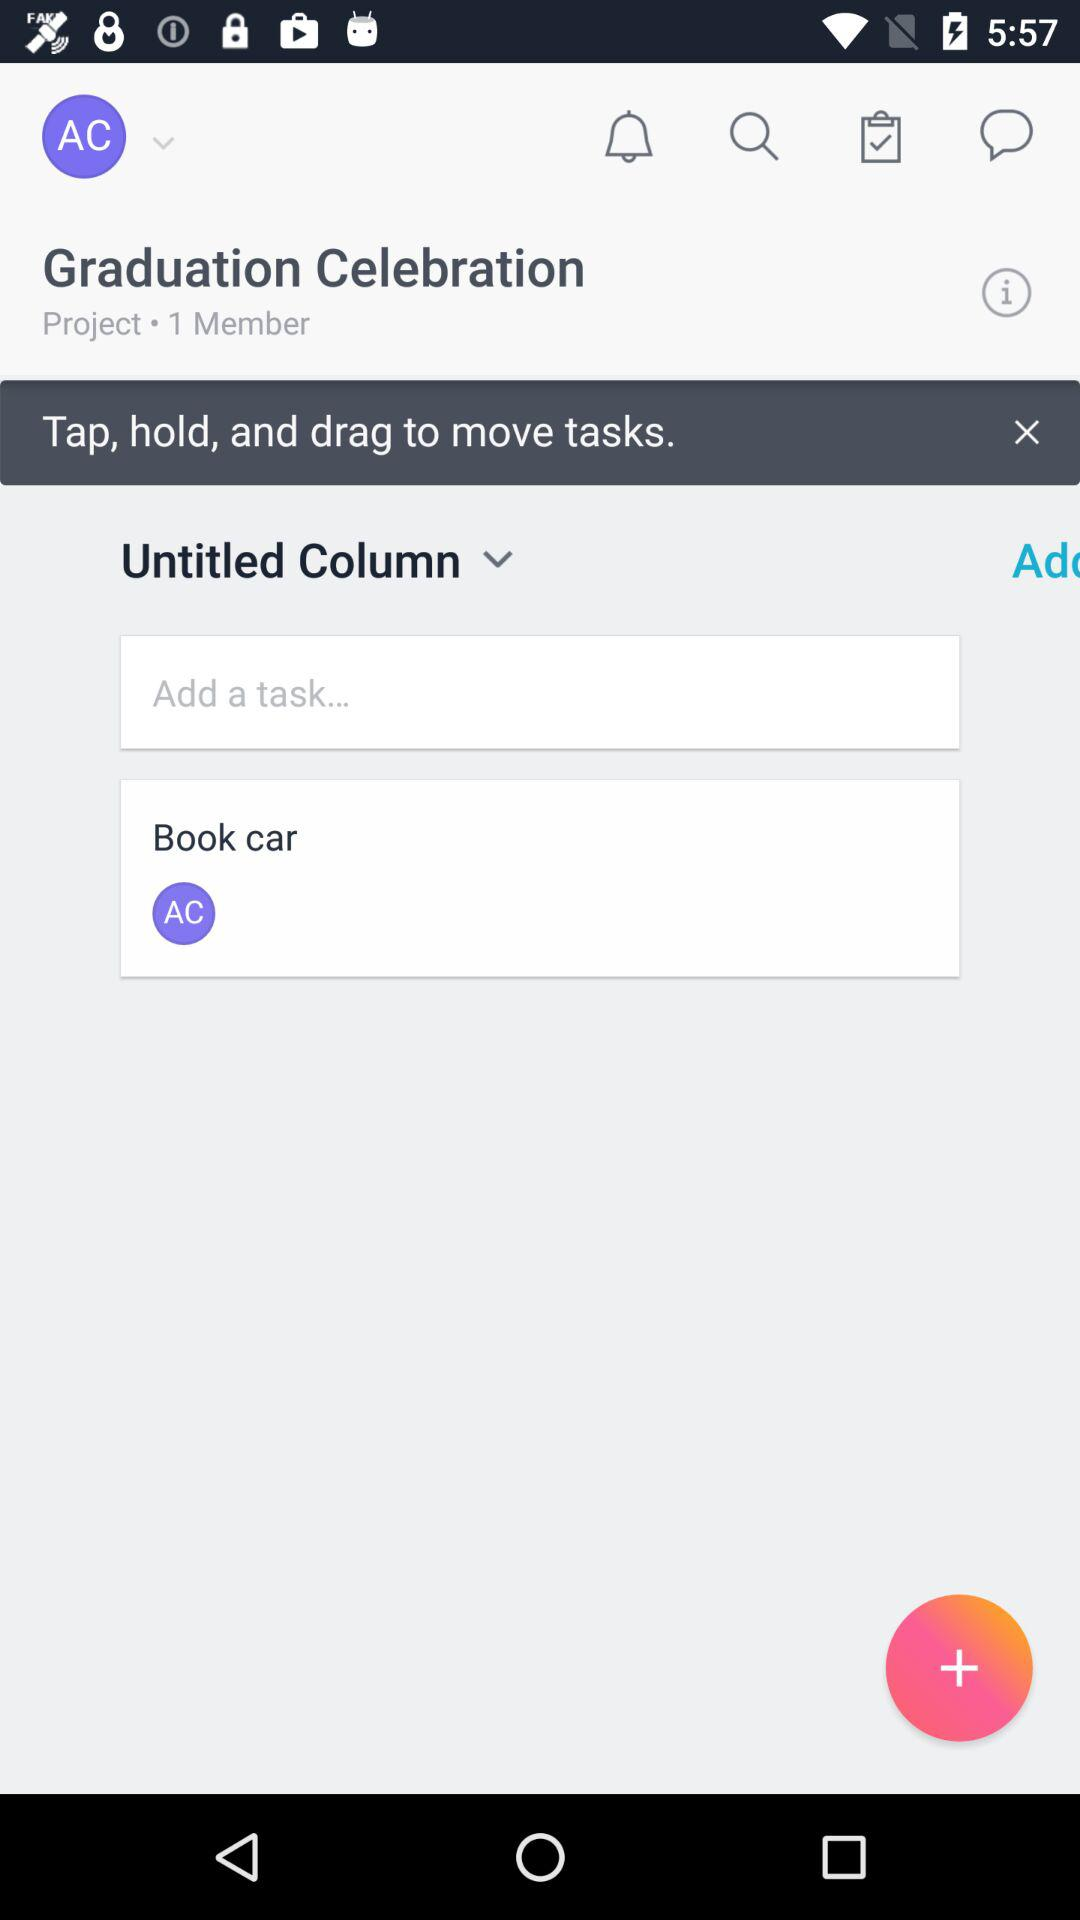How many members are in the project?
Answer the question using a single word or phrase. 1 